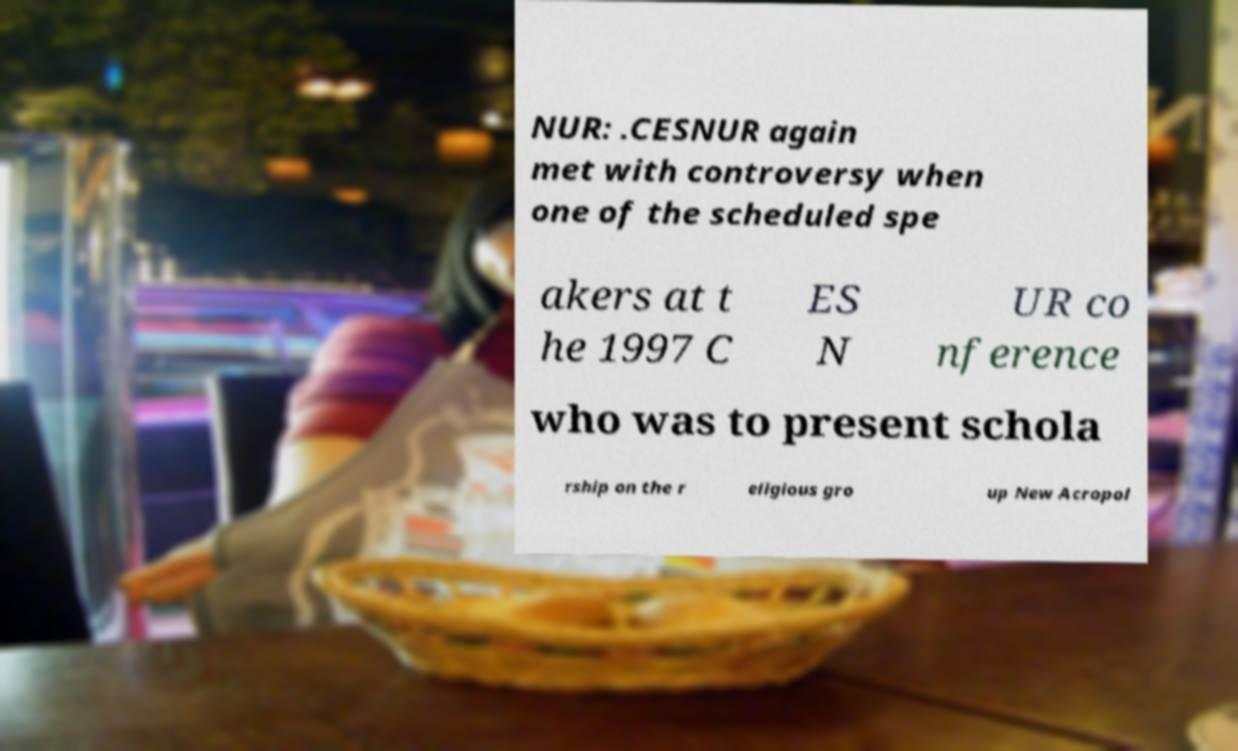What messages or text are displayed in this image? I need them in a readable, typed format. NUR: .CESNUR again met with controversy when one of the scheduled spe akers at t he 1997 C ES N UR co nference who was to present schola rship on the r eligious gro up New Acropol 